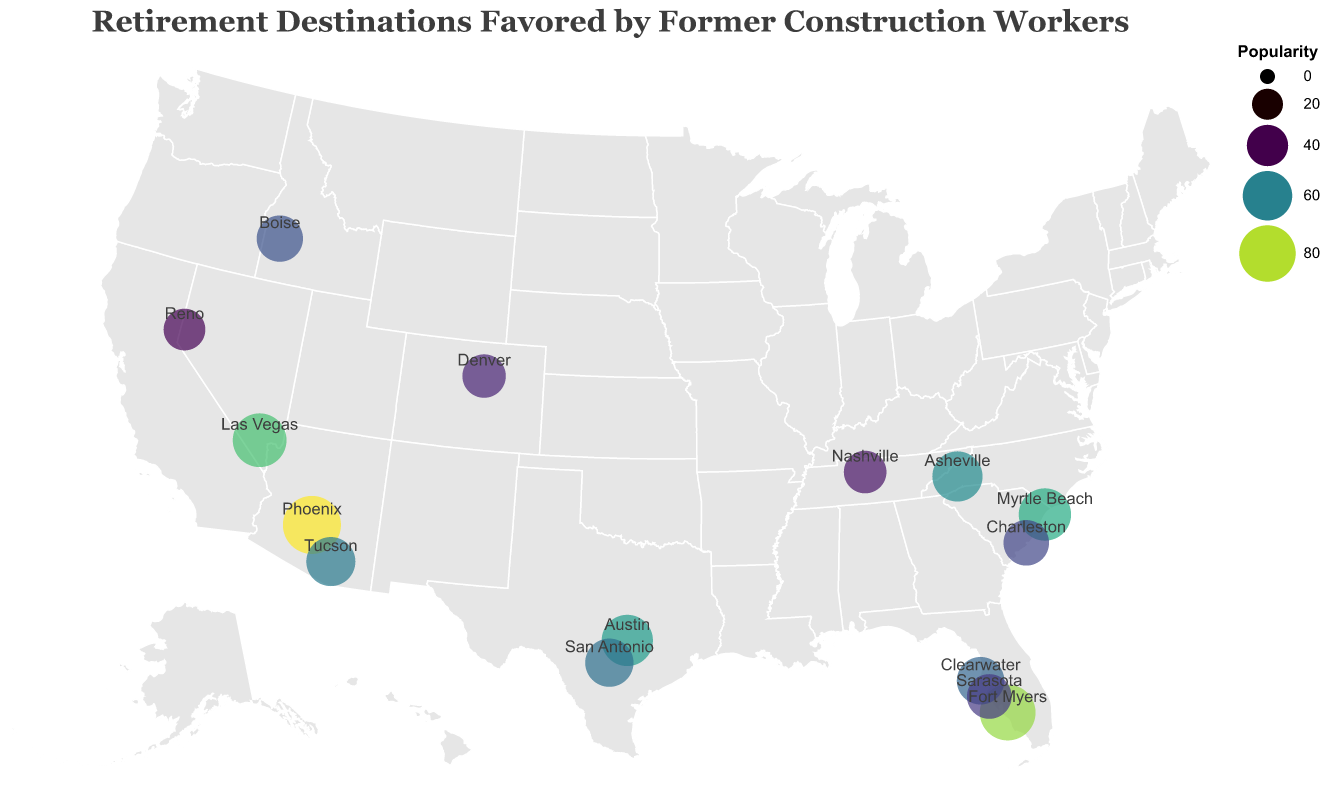What is the most popular retirement destination for former construction workers? The size and color of the circles on the map represent popularity. The largest and most brightly colored circle is in Phoenix, Arizona.
Answer: Phoenix, Arizona Which state has the highest number of popular retirement destinations? Florida has three cities listed: Fort Myers, Clearwater, and Sarasota.
Answer: Florida Are there any retirement destinations located in Texas? Checking the map, there are circles in Austin and San Antonio, both located in Texas.
Answer: Yes, Austin and San Antonio Which city in South Carolina is more popular, Myrtle Beach or Charleston? Comparing the sizes of the circles in Myrtle Beach and Charleston, Myrtle Beach has the larger circle, indicating higher popularity.
Answer: Myrtle Beach Which retirement destination has a popularity score closest to 50? Checking the data provided, Charleston in South Carolina has a popularity score of 50.
Answer: Charleston, South Carolina How many states have more than one popular retirement destination listed? Looking at the map and list, Florida, Texas, Arizona, and Nevada each have two or more cities listed, so there are 4 states.
Answer: 4 What is the least popular destination on the list? The circle for Reno, Nevada is the smallest and least brightly colored which corresponds to the lowest popularity score.
Answer: Reno, Nevada What is the combined popularity of all the retirement destinations in Florida? Adding up the popularity scores for Fort Myers (78), Clearwater (55), and Sarasota (48) totals to 181.
Answer: 181 Compare the popularity of cities in Arizona. Which one is more favored? Phoenix (85) and Tucson (59) are the Arizona cities listed; Phoenix has a higher popularity score.
Answer: Phoenix Are there any retirement destinations listed in the Western United States? The map shows circles in Phoenix, Las Vegas, Tucson, Reno, and Boise, which are all in the Western United States.
Answer: Yes How does the popularity of Denver compare to Nashville? Denver has a popularity score of 45, while Nashville's score is 43. Denver is slightly more popular than Nashville.
Answer: Denver 